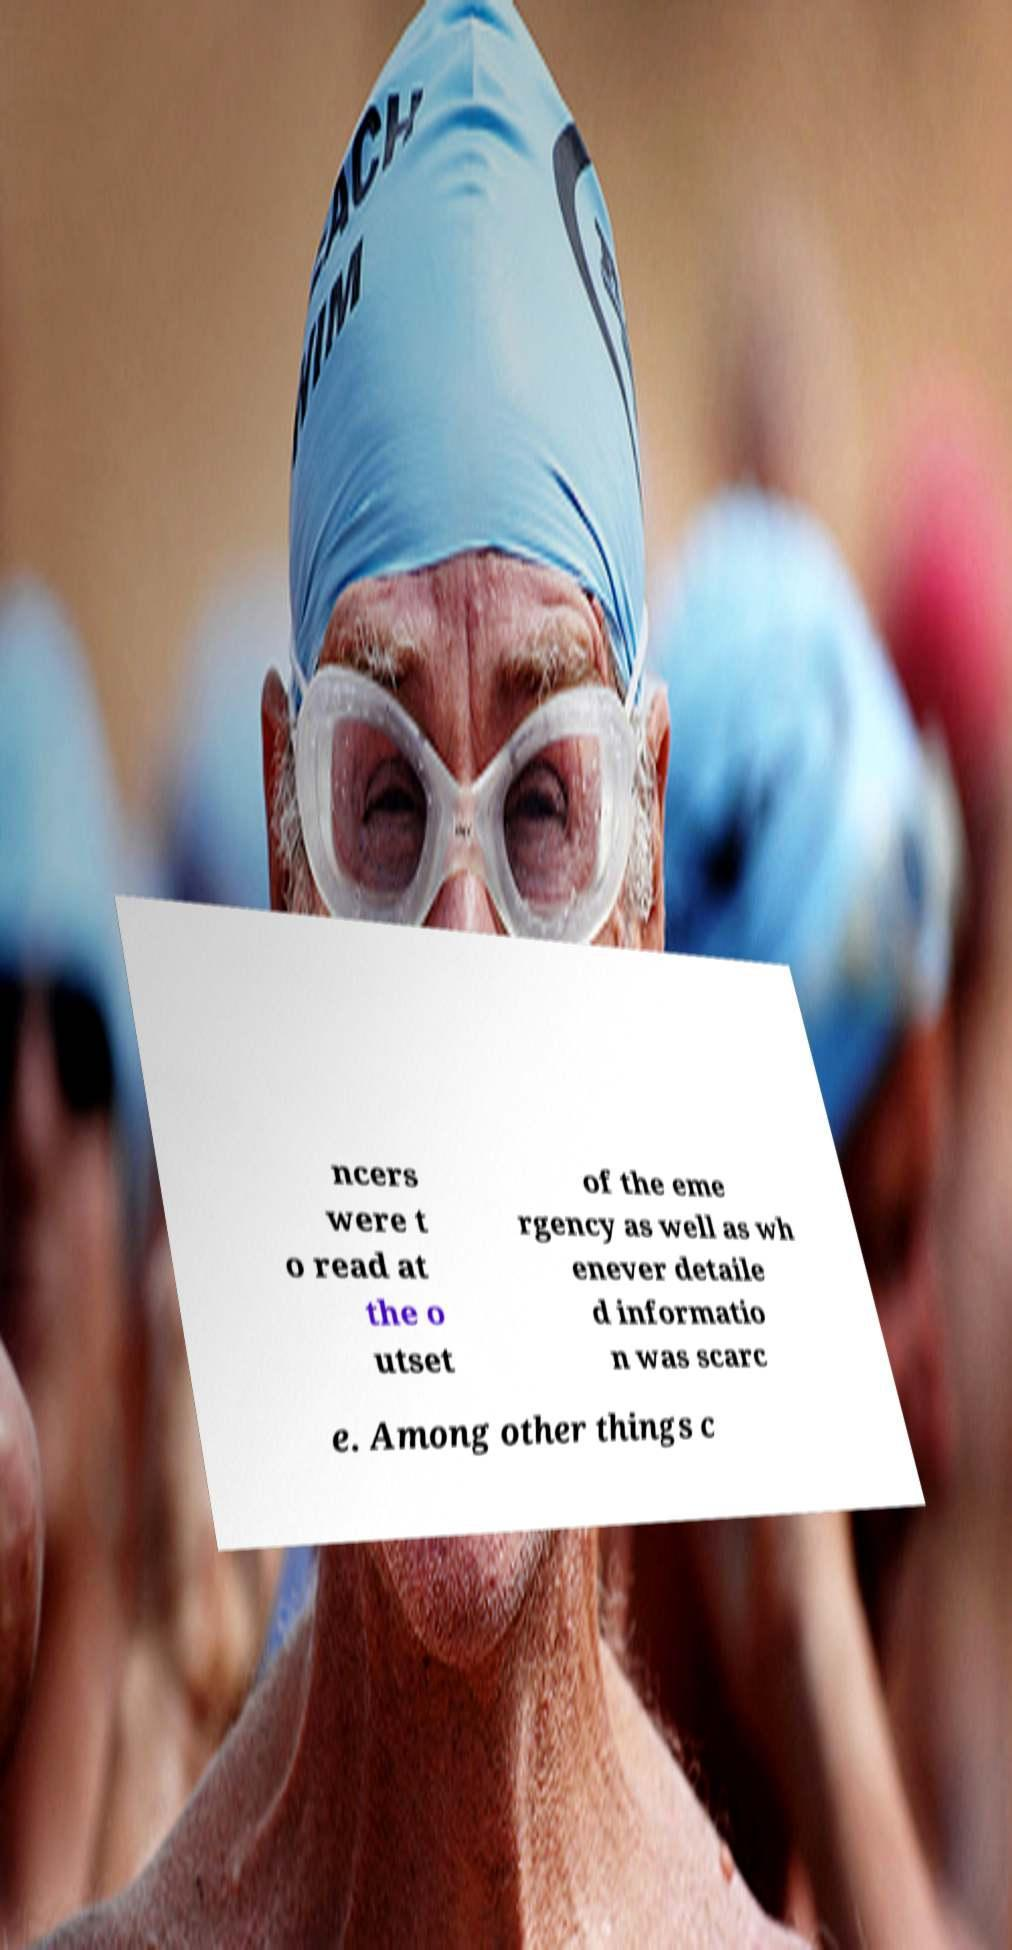For documentation purposes, I need the text within this image transcribed. Could you provide that? ncers were t o read at the o utset of the eme rgency as well as wh enever detaile d informatio n was scarc e. Among other things c 